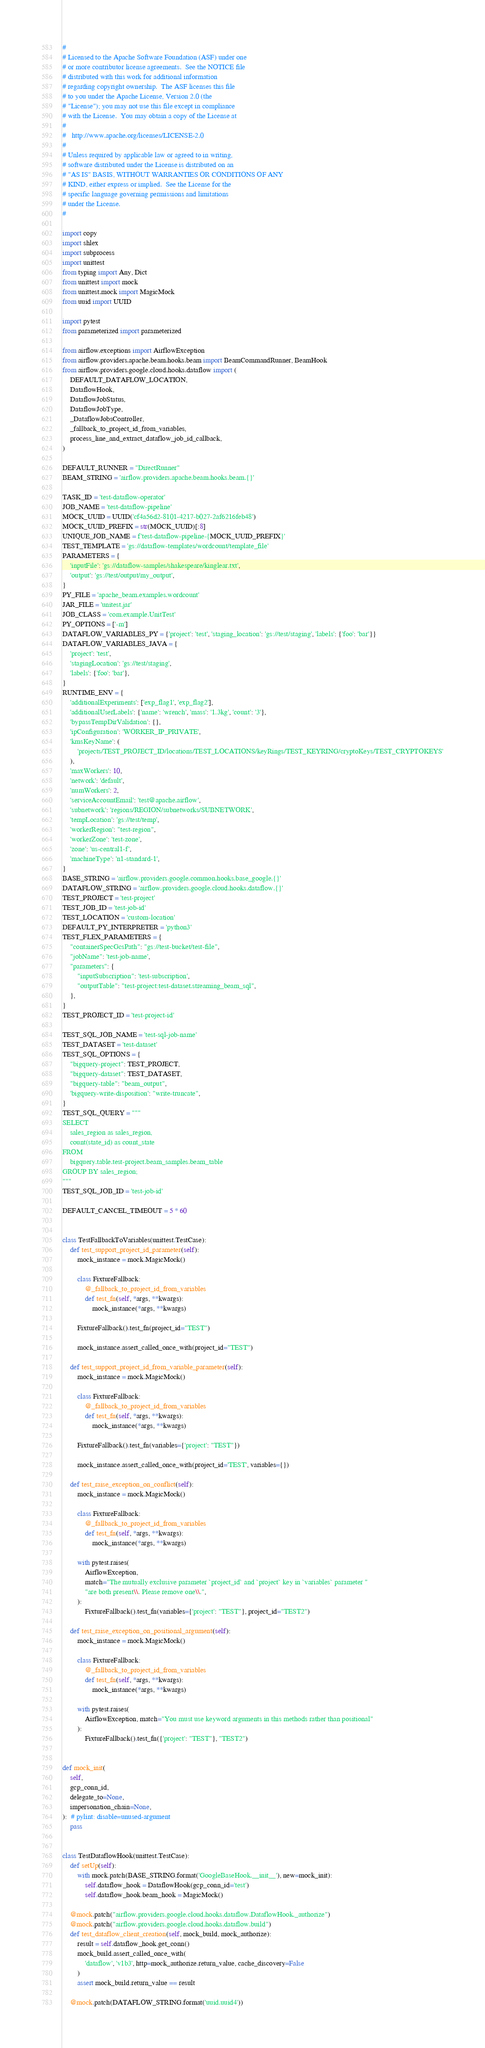Convert code to text. <code><loc_0><loc_0><loc_500><loc_500><_Python_>#
# Licensed to the Apache Software Foundation (ASF) under one
# or more contributor license agreements.  See the NOTICE file
# distributed with this work for additional information
# regarding copyright ownership.  The ASF licenses this file
# to you under the Apache License, Version 2.0 (the
# "License"); you may not use this file except in compliance
# with the License.  You may obtain a copy of the License at
#
#   http://www.apache.org/licenses/LICENSE-2.0
#
# Unless required by applicable law or agreed to in writing,
# software distributed under the License is distributed on an
# "AS IS" BASIS, WITHOUT WARRANTIES OR CONDITIONS OF ANY
# KIND, either express or implied.  See the License for the
# specific language governing permissions and limitations
# under the License.
#

import copy
import shlex
import subprocess
import unittest
from typing import Any, Dict
from unittest import mock
from unittest.mock import MagicMock
from uuid import UUID

import pytest
from parameterized import parameterized

from airflow.exceptions import AirflowException
from airflow.providers.apache.beam.hooks.beam import BeamCommandRunner, BeamHook
from airflow.providers.google.cloud.hooks.dataflow import (
    DEFAULT_DATAFLOW_LOCATION,
    DataflowHook,
    DataflowJobStatus,
    DataflowJobType,
    _DataflowJobsController,
    _fallback_to_project_id_from_variables,
    process_line_and_extract_dataflow_job_id_callback,
)

DEFAULT_RUNNER = "DirectRunner"
BEAM_STRING = 'airflow.providers.apache.beam.hooks.beam.{}'

TASK_ID = 'test-dataflow-operator'
JOB_NAME = 'test-dataflow-pipeline'
MOCK_UUID = UUID('cf4a56d2-8101-4217-b027-2af6216feb48')
MOCK_UUID_PREFIX = str(MOCK_UUID)[:8]
UNIQUE_JOB_NAME = f'test-dataflow-pipeline-{MOCK_UUID_PREFIX}'
TEST_TEMPLATE = 'gs://dataflow-templates/wordcount/template_file'
PARAMETERS = {
    'inputFile': 'gs://dataflow-samples/shakespeare/kinglear.txt',
    'output': 'gs://test/output/my_output',
}
PY_FILE = 'apache_beam.examples.wordcount'
JAR_FILE = 'unitest.jar'
JOB_CLASS = 'com.example.UnitTest'
PY_OPTIONS = ['-m']
DATAFLOW_VARIABLES_PY = {'project': 'test', 'staging_location': 'gs://test/staging', 'labels': {'foo': 'bar'}}
DATAFLOW_VARIABLES_JAVA = {
    'project': 'test',
    'stagingLocation': 'gs://test/staging',
    'labels': {'foo': 'bar'},
}
RUNTIME_ENV = {
    'additionalExperiments': ['exp_flag1', 'exp_flag2'],
    'additionalUserLabels': {'name': 'wrench', 'mass': '1.3kg', 'count': '3'},
    'bypassTempDirValidation': {},
    'ipConfiguration': 'WORKER_IP_PRIVATE',
    'kmsKeyName': (
        'projects/TEST_PROJECT_ID/locations/TEST_LOCATIONS/keyRings/TEST_KEYRING/cryptoKeys/TEST_CRYPTOKEYS'
    ),
    'maxWorkers': 10,
    'network': 'default',
    'numWorkers': 2,
    'serviceAccountEmail': 'test@apache.airflow',
    'subnetwork': 'regions/REGION/subnetworks/SUBNETWORK',
    'tempLocation': 'gs://test/temp',
    'workerRegion': "test-region",
    'workerZone': 'test-zone',
    'zone': 'us-central1-f',
    'machineType': 'n1-standard-1',
}
BASE_STRING = 'airflow.providers.google.common.hooks.base_google.{}'
DATAFLOW_STRING = 'airflow.providers.google.cloud.hooks.dataflow.{}'
TEST_PROJECT = 'test-project'
TEST_JOB_ID = 'test-job-id'
TEST_LOCATION = 'custom-location'
DEFAULT_PY_INTERPRETER = 'python3'
TEST_FLEX_PARAMETERS = {
    "containerSpecGcsPath": "gs://test-bucket/test-file",
    "jobName": 'test-job-name',
    "parameters": {
        "inputSubscription": 'test-subscription',
        "outputTable": "test-project:test-dataset.streaming_beam_sql",
    },
}
TEST_PROJECT_ID = 'test-project-id'

TEST_SQL_JOB_NAME = 'test-sql-job-name'
TEST_DATASET = 'test-dataset'
TEST_SQL_OPTIONS = {
    "bigquery-project": TEST_PROJECT,
    "bigquery-dataset": TEST_DATASET,
    "bigquery-table": "beam_output",
    'bigquery-write-disposition': "write-truncate",
}
TEST_SQL_QUERY = """
SELECT
    sales_region as sales_region,
    count(state_id) as count_state
FROM
    bigquery.table.test-project.beam_samples.beam_table
GROUP BY sales_region;
"""
TEST_SQL_JOB_ID = 'test-job-id'

DEFAULT_CANCEL_TIMEOUT = 5 * 60


class TestFallbackToVariables(unittest.TestCase):
    def test_support_project_id_parameter(self):
        mock_instance = mock.MagicMock()

        class FixtureFallback:
            @_fallback_to_project_id_from_variables
            def test_fn(self, *args, **kwargs):
                mock_instance(*args, **kwargs)

        FixtureFallback().test_fn(project_id="TEST")

        mock_instance.assert_called_once_with(project_id="TEST")

    def test_support_project_id_from_variable_parameter(self):
        mock_instance = mock.MagicMock()

        class FixtureFallback:
            @_fallback_to_project_id_from_variables
            def test_fn(self, *args, **kwargs):
                mock_instance(*args, **kwargs)

        FixtureFallback().test_fn(variables={'project': "TEST"})

        mock_instance.assert_called_once_with(project_id='TEST', variables={})

    def test_raise_exception_on_conflict(self):
        mock_instance = mock.MagicMock()

        class FixtureFallback:
            @_fallback_to_project_id_from_variables
            def test_fn(self, *args, **kwargs):
                mock_instance(*args, **kwargs)

        with pytest.raises(
            AirflowException,
            match="The mutually exclusive parameter `project_id` and `project` key in `variables` parameter "
            "are both present\\. Please remove one\\.",
        ):
            FixtureFallback().test_fn(variables={'project': "TEST"}, project_id="TEST2")

    def test_raise_exception_on_positional_argument(self):
        mock_instance = mock.MagicMock()

        class FixtureFallback:
            @_fallback_to_project_id_from_variables
            def test_fn(self, *args, **kwargs):
                mock_instance(*args, **kwargs)

        with pytest.raises(
            AirflowException, match="You must use keyword arguments in this methods rather than positional"
        ):
            FixtureFallback().test_fn({'project': "TEST"}, "TEST2")


def mock_init(
    self,
    gcp_conn_id,
    delegate_to=None,
    impersonation_chain=None,
):  # pylint: disable=unused-argument
    pass


class TestDataflowHook(unittest.TestCase):
    def setUp(self):
        with mock.patch(BASE_STRING.format('GoogleBaseHook.__init__'), new=mock_init):
            self.dataflow_hook = DataflowHook(gcp_conn_id='test')
            self.dataflow_hook.beam_hook = MagicMock()

    @mock.patch("airflow.providers.google.cloud.hooks.dataflow.DataflowHook._authorize")
    @mock.patch("airflow.providers.google.cloud.hooks.dataflow.build")
    def test_dataflow_client_creation(self, mock_build, mock_authorize):
        result = self.dataflow_hook.get_conn()
        mock_build.assert_called_once_with(
            'dataflow', 'v1b3', http=mock_authorize.return_value, cache_discovery=False
        )
        assert mock_build.return_value == result

    @mock.patch(DATAFLOW_STRING.format('uuid.uuid4'))</code> 